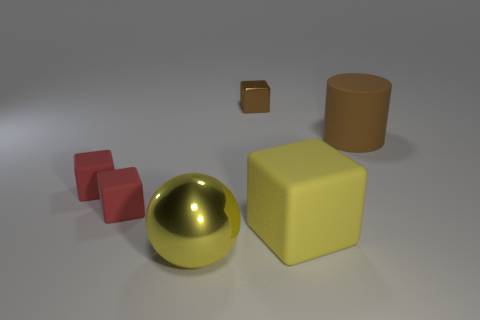Subtract all shiny blocks. How many blocks are left? 3 Subtract all blue cylinders. How many red cubes are left? 2 Add 1 large yellow cubes. How many objects exist? 7 Subtract all brown blocks. How many blocks are left? 3 Subtract all cubes. How many objects are left? 2 Add 1 yellow matte cubes. How many yellow matte cubes exist? 2 Subtract 0 red cylinders. How many objects are left? 6 Subtract all yellow cubes. Subtract all red spheres. How many cubes are left? 3 Subtract all small shiny objects. Subtract all gray blocks. How many objects are left? 5 Add 4 tiny rubber objects. How many tiny rubber objects are left? 6 